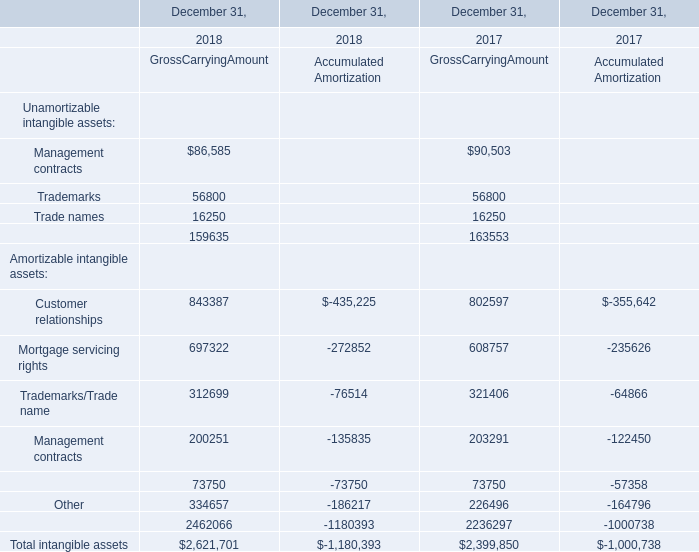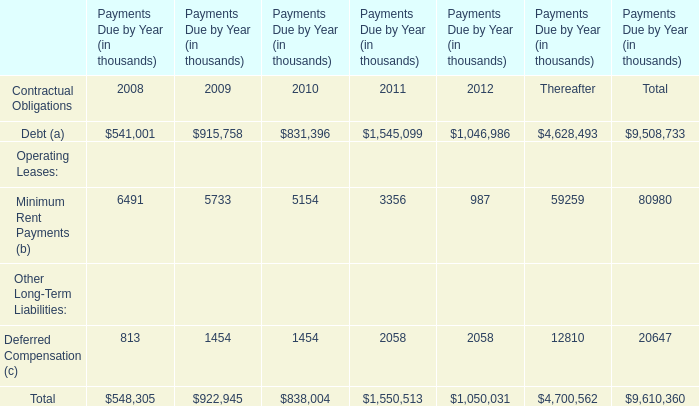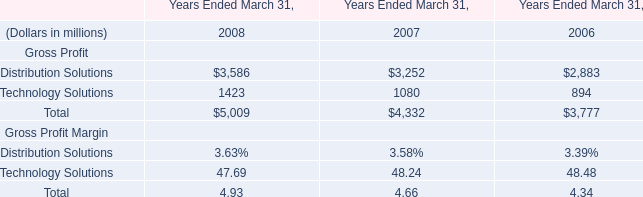What's the current growth rate of mortgage servicing rights of Gross carrying amount? 
Computations: ((697322 - 608757) / 608757)
Answer: 0.14548. 